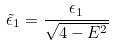<formula> <loc_0><loc_0><loc_500><loc_500>\tilde { \epsilon } _ { 1 } = \frac { \epsilon _ { 1 } } { \sqrt { 4 - E ^ { 2 } } }</formula> 